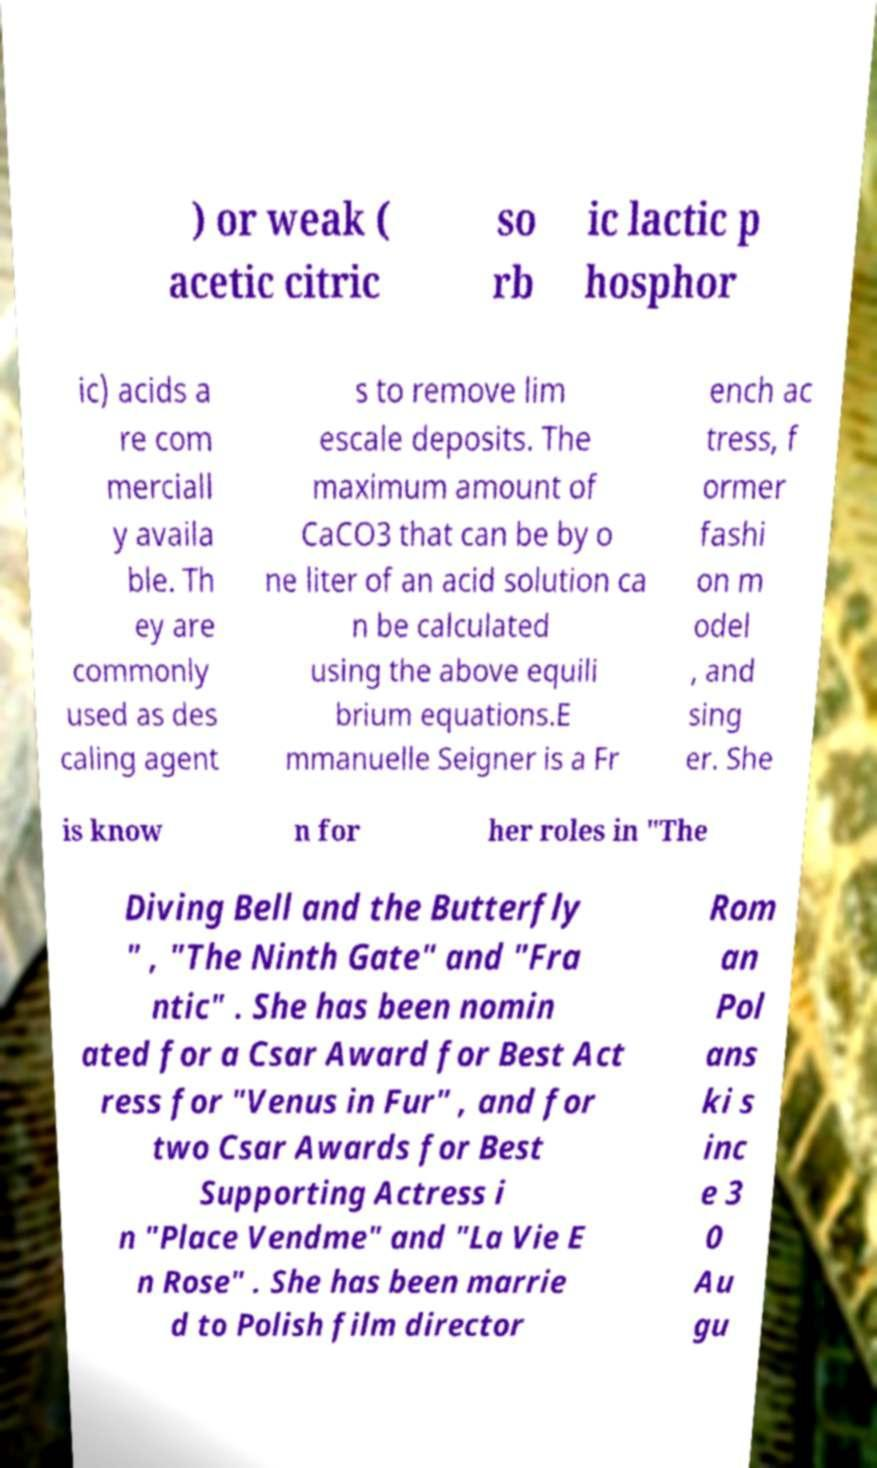I need the written content from this picture converted into text. Can you do that? ) or weak ( acetic citric so rb ic lactic p hosphor ic) acids a re com merciall y availa ble. Th ey are commonly used as des caling agent s to remove lim escale deposits. The maximum amount of CaCO3 that can be by o ne liter of an acid solution ca n be calculated using the above equili brium equations.E mmanuelle Seigner is a Fr ench ac tress, f ormer fashi on m odel , and sing er. She is know n for her roles in "The Diving Bell and the Butterfly " , "The Ninth Gate" and "Fra ntic" . She has been nomin ated for a Csar Award for Best Act ress for "Venus in Fur" , and for two Csar Awards for Best Supporting Actress i n "Place Vendme" and "La Vie E n Rose" . She has been marrie d to Polish film director Rom an Pol ans ki s inc e 3 0 Au gu 